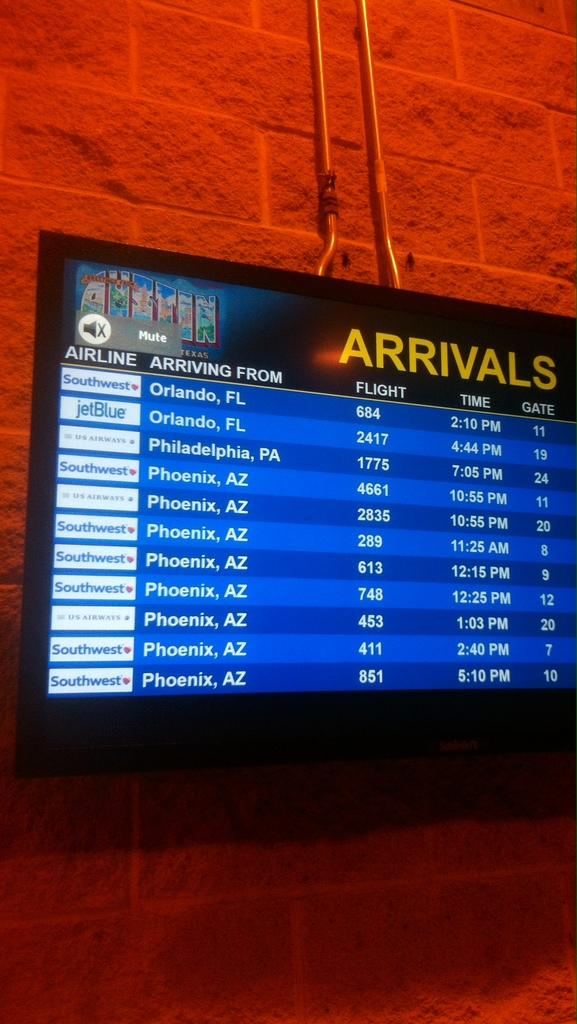<image>
Present a compact description of the photo's key features. An arrivals board displays what time different airlines are schedule to land. 